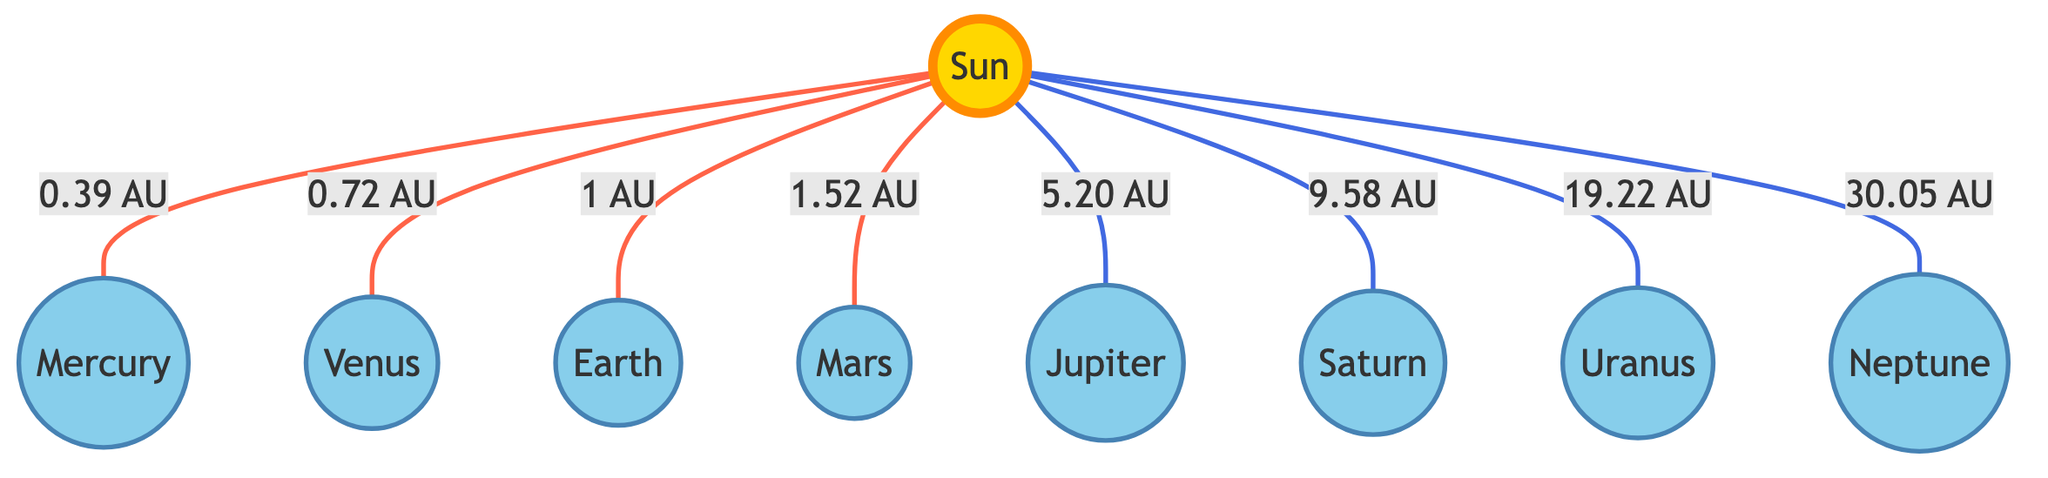What is the distance from the Sun to Mars? The diagram shows a direct line connecting the Sun to Mars, labeled with the distance of 1.52 AU.
Answer: 1.52 AU Which planet is closest to the Sun? The diagram indicates that Mercury is directly connected to the Sun with the smallest distance, which is 0.39 AU.
Answer: Mercury How many planets are depicted in the diagram? By counting all the planetary nodes connected to the Sun, there are a total of eight planets shown in the diagram.
Answer: 8 What is the distance from the Sun to Neptune? The diagram shows a line from the Sun to Neptune with the distance noted as 30.05 AU.
Answer: 30.05 AU Which planet has an orbital distance greater than 10 AU from the Sun? In the diagram, Saturn (9.58 AU), Uranus (19.22 AU), and Neptune (30.05 AU) are connected to the Sun, but only Uranus (19.22 AU) and Neptune (30.05 AU) exceed 10 AU.
Answer: Uranus, Neptune How does the distance of Jupiter compare to that of Earth? The diagram shows Jupiter at 5.20 AU and Earth at 1 AU. Since 5.20 AU is greater than 1 AU, Jupiter's distance is greater than Earth’s distance from the Sun.
Answer: Greater What color represents the planets in the diagram? The diagram uses the color #87CEEB (light blue) for all planetary nodes, as indicated by the class definition for planets.
Answer: Light blue Which planet is further away from the Sun, Saturn or Venus? The diagram labels Venus with 0.72 AU and Saturn with 9.58 AU, indicating that Saturn is further from the Sun than Venus.
Answer: Saturn 